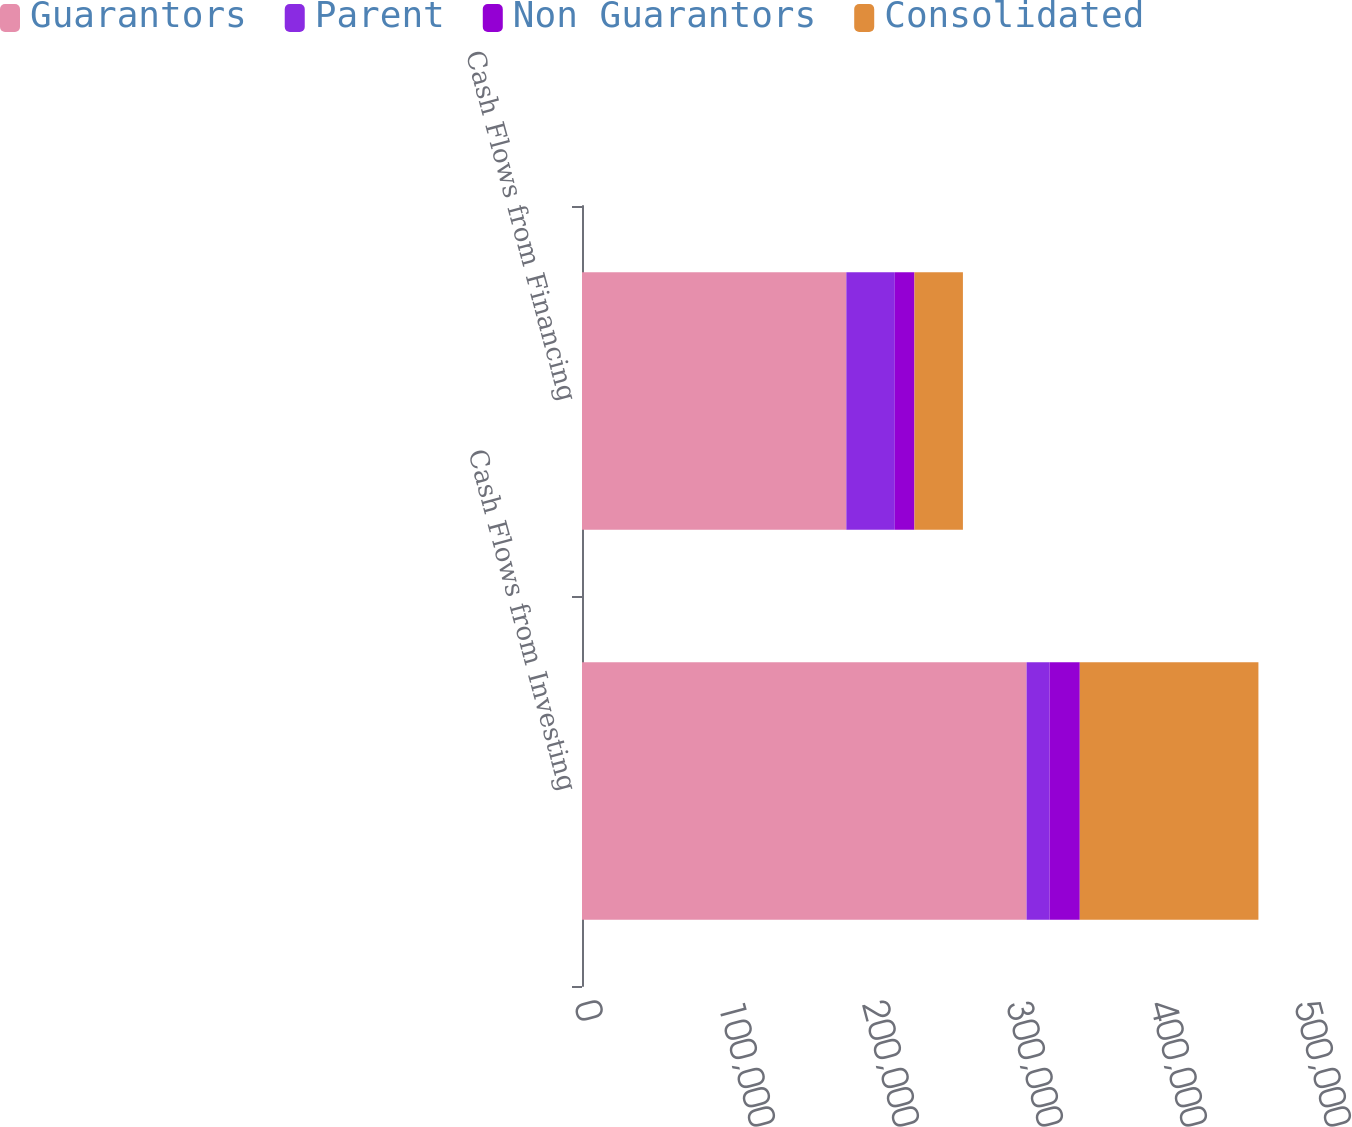<chart> <loc_0><loc_0><loc_500><loc_500><stacked_bar_chart><ecel><fcel>Cash Flows from Investing<fcel>Cash Flows from Financing<nl><fcel>Guarantors<fcel>308743<fcel>183564<nl><fcel>Parent<fcel>16033<fcel>33662<nl><fcel>Non Guarantors<fcel>20915<fcel>13640<nl><fcel>Consolidated<fcel>124042<fcel>33662<nl></chart> 